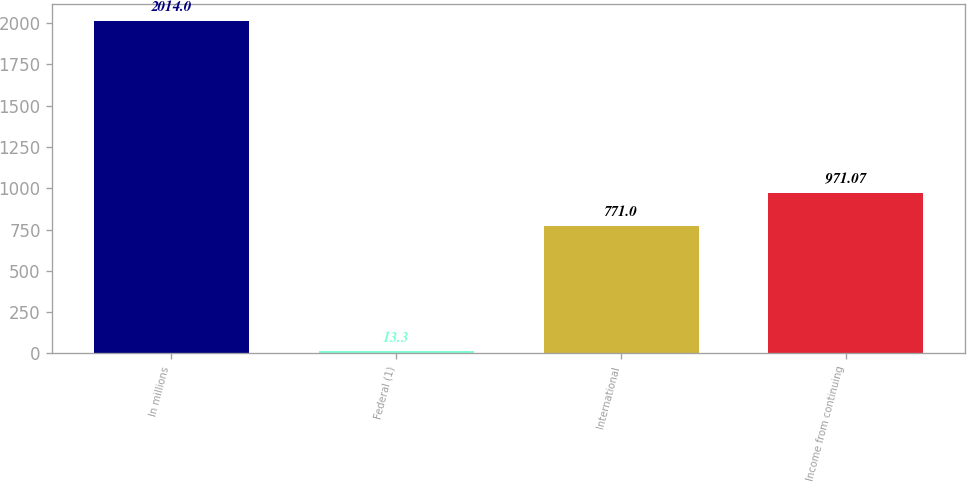<chart> <loc_0><loc_0><loc_500><loc_500><bar_chart><fcel>In millions<fcel>Federal (1)<fcel>International<fcel>Income from continuing<nl><fcel>2014<fcel>13.3<fcel>771<fcel>971.07<nl></chart> 